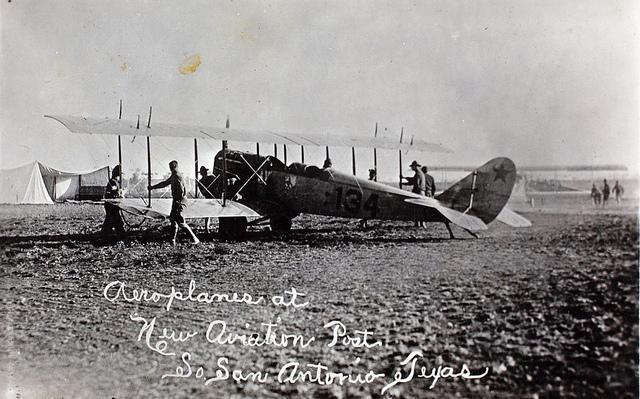How many zebras can you count?
Give a very brief answer. 0. 